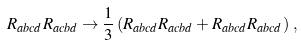<formula> <loc_0><loc_0><loc_500><loc_500>R _ { a b c d } R _ { a c b d } \rightarrow \frac { 1 } { 3 } \left ( R _ { a b c d } R _ { a c b d } + R _ { a b c d } R _ { a b c d } \right ) \, ,</formula> 